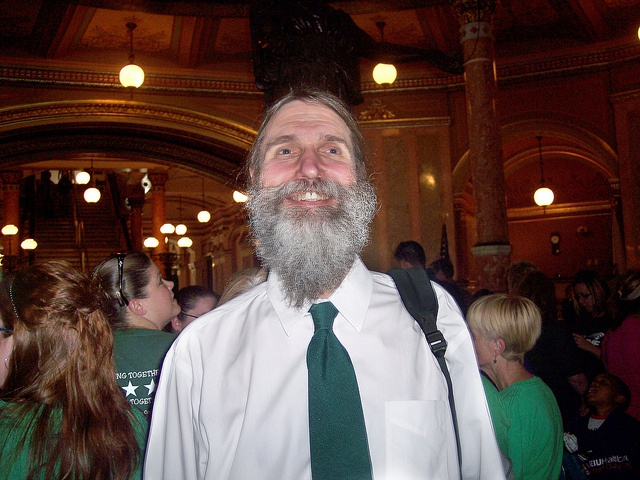Describe the objects in this image and their specific colors. I can see people in black, lightgray, darkgray, teal, and gray tones, people in black, maroon, and gray tones, people in black, teal, darkgreen, and gray tones, people in black, teal, and gray tones, and tie in black, teal, and darkblue tones in this image. 